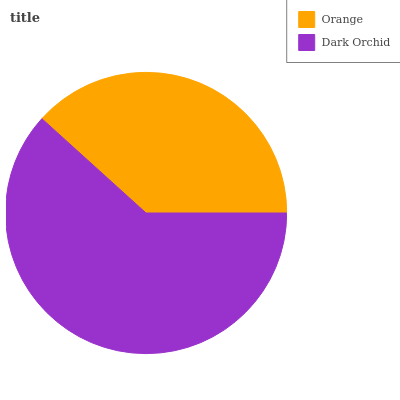Is Orange the minimum?
Answer yes or no. Yes. Is Dark Orchid the maximum?
Answer yes or no. Yes. Is Dark Orchid the minimum?
Answer yes or no. No. Is Dark Orchid greater than Orange?
Answer yes or no. Yes. Is Orange less than Dark Orchid?
Answer yes or no. Yes. Is Orange greater than Dark Orchid?
Answer yes or no. No. Is Dark Orchid less than Orange?
Answer yes or no. No. Is Dark Orchid the high median?
Answer yes or no. Yes. Is Orange the low median?
Answer yes or no. Yes. Is Orange the high median?
Answer yes or no. No. Is Dark Orchid the low median?
Answer yes or no. No. 